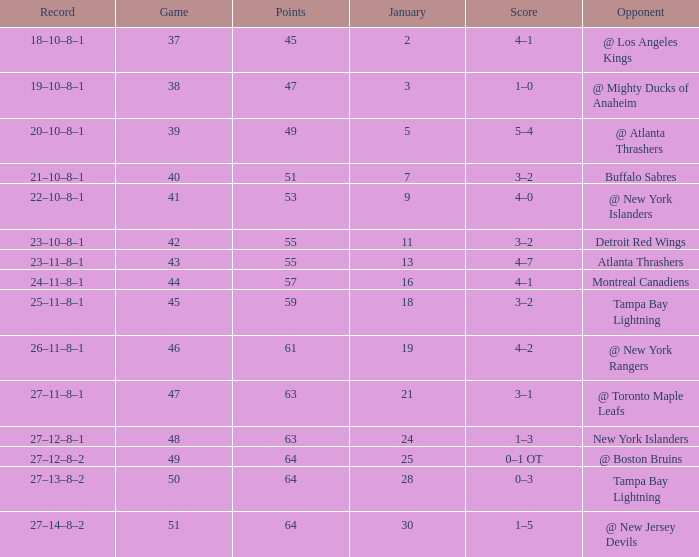Could you parse the entire table as a dict? {'header': ['Record', 'Game', 'Points', 'January', 'Score', 'Opponent'], 'rows': [['18–10–8–1', '37', '45', '2', '4–1', '@ Los Angeles Kings'], ['19–10–8–1', '38', '47', '3', '1–0', '@ Mighty Ducks of Anaheim'], ['20–10–8–1', '39', '49', '5', '5–4', '@ Atlanta Thrashers'], ['21–10–8–1', '40', '51', '7', '3–2', 'Buffalo Sabres'], ['22–10–8–1', '41', '53', '9', '4–0', '@ New York Islanders'], ['23–10–8–1', '42', '55', '11', '3–2', 'Detroit Red Wings'], ['23–11–8–1', '43', '55', '13', '4–7', 'Atlanta Thrashers'], ['24–11–8–1', '44', '57', '16', '4–1', 'Montreal Canadiens'], ['25–11–8–1', '45', '59', '18', '3–2', 'Tampa Bay Lightning'], ['26–11–8–1', '46', '61', '19', '4–2', '@ New York Rangers'], ['27–11–8–1', '47', '63', '21', '3–1', '@ Toronto Maple Leafs'], ['27–12–8–1', '48', '63', '24', '1–3', 'New York Islanders'], ['27–12–8–2', '49', '64', '25', '0–1 OT', '@ Boston Bruins'], ['27–13–8–2', '50', '64', '28', '0–3', 'Tampa Bay Lightning'], ['27–14–8–2', '51', '64', '30', '1–5', '@ New Jersey Devils']]} Which Points have a Score of 4–1, and a Record of 18–10–8–1, and a January larger than 2? None. 